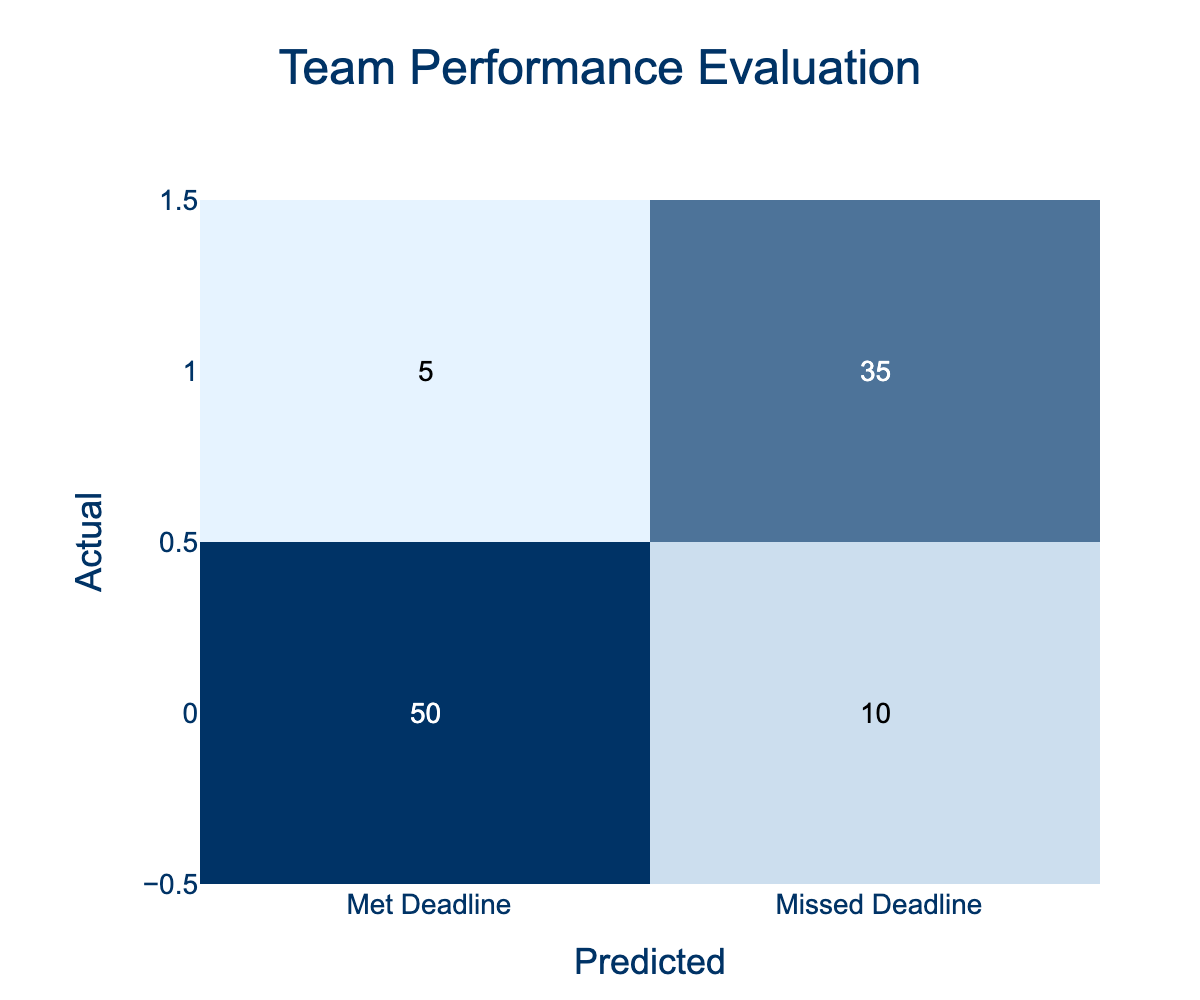What is the number of predictions for teams that met their deadlines? The table shows that the number of teams that met their deadlines is indicated in the "Met Deadline" row under the "Met Deadline" column, which has a value of 50.
Answer: 50 What is the total number of teams that missed deadlines? To find the total number of teams that missed their deadlines, we look at the "Missed Deadline" row and sum the values in that row: 5 (predicted as met) + 35 (predicted as missed) = 40.
Answer: 40 Is it true that more teams met their deadlines than missed them? We need to compare the total number of teams that met their deadlines (60) with those that missed them (40). Since 60 is greater than 40, this statement is true.
Answer: Yes What percentage of teams predicted to meet the deadline actually met it? To find the percentage, we divide the number of teams that actually met the deadline (50) by the total number predicted (50 + 10 = 60) and multiply by 100. The calculation gives (50/60) * 100 = approximately 83.33%.
Answer: 83.33% What is the difference between the number of teams that missed the deadline and those that were correctly predicted to meet it? The number of teams that missed the deadline is 40, while those correctly predicted to meet it is 50. The difference is 40 - 50 = -10, indicating that there were 10 more teams correctly predicted to meet their deadlines.
Answer: -10 How many teams were incorrectly predicted to meet their deadline? The value in the "Met Deadline" row under the "Missed Deadline" column indicates how many teams were incorrectly predicted to meet their deadline, which is 10.
Answer: 10 If all teams that missed their deadlines were correctly predicted, what would the total number have been? The total number of teams that missed their deadlines is found in the "Missed Deadline" row. Since they missed is 35, adding this to the correctly predicted met teams (50), gives us a total of 35 + 35 = 70.
Answer: 70 What is the ratio of teams that met their deadlines to those that missed? We take the numbers from the table: teams that met deadlines (60) and those that missed deadlines (40). The ratio is 60:40, which simplifies to 3:2.
Answer: 3:2 How many total predictions did the team make? To find out the total number of predictions, we sum all the values in the confusion matrix: 50 (met met) + 10 (met missed) + 5 (missed met) + 35 (missed missed) = 100.
Answer: 100 